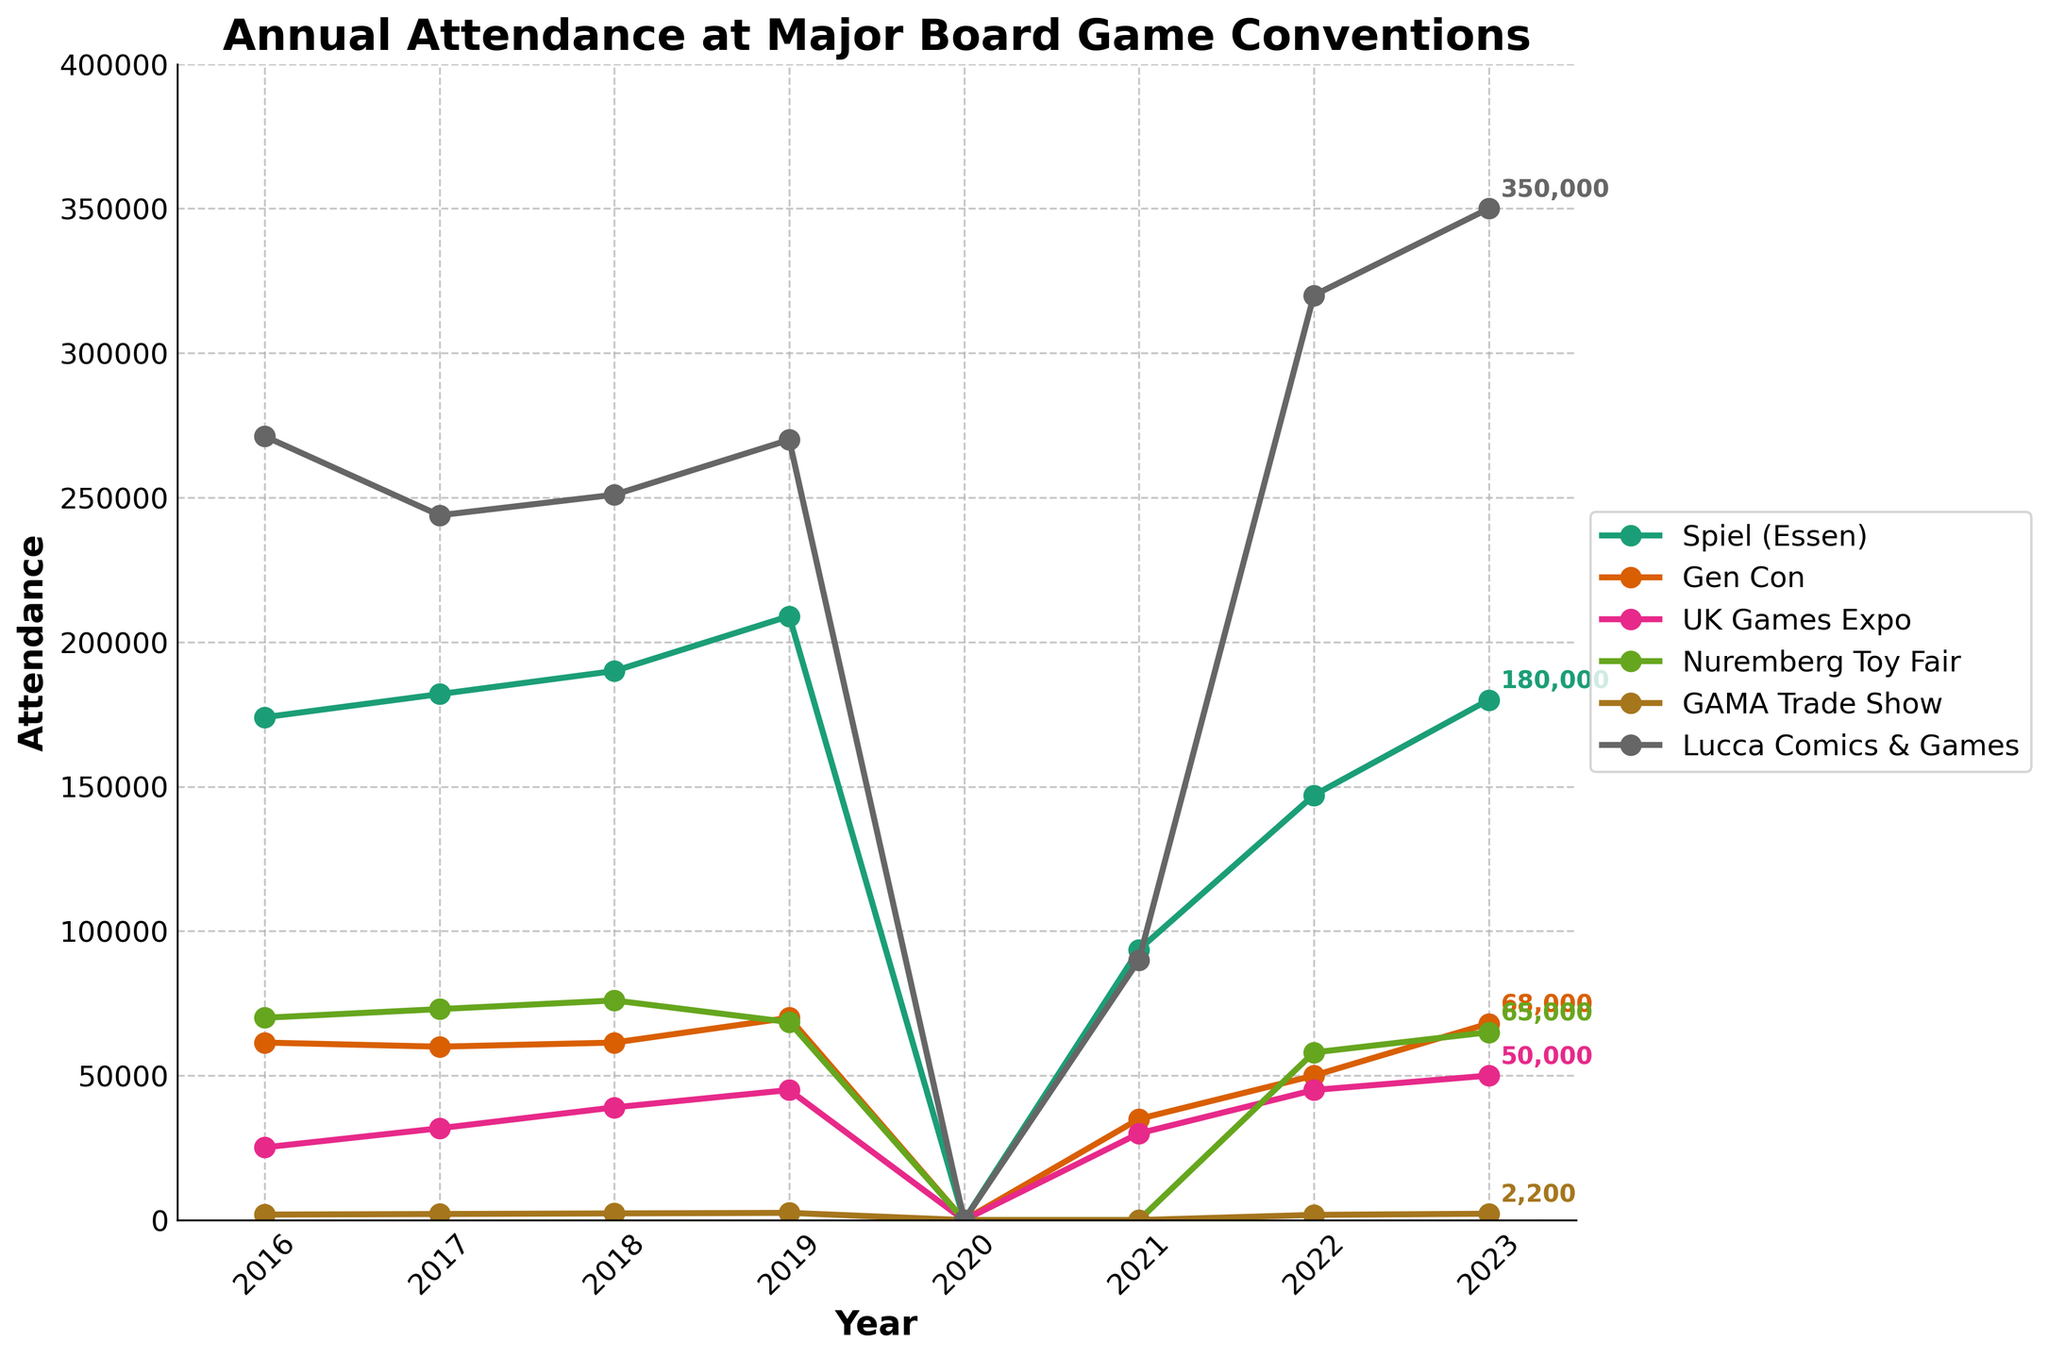What was the attendance at Spiel (Essen) in 2019 compared to Gen Con in the same year? Look at Spiel (Essen) and Gen Con attendance in 2019. Spiel (Essen) had 209,000 attendees and Gen Con had 70,000 attendees.
Answer: Spiel (Essen): 209,000, Gen Con: 70,000 Which convention had the highest attendance in 2023? Check the attendance figures for all conventions in 2023. Lucca Comics & Games had the highest attendance with 350,000 attendees.
Answer: Lucca Comics & Games How did UK Games Expo attendance change from 2016 to 2023? In 2016, UK Games Expo had 25,149 attendees; by 2023, it had 50,000 attendees. The attendance increased by 50,000 - 25,149 = 24,851 attendees.
Answer: Increased by 24,851 Which convention showed the most consistent increase in attendance from 2016 to 2023? Generate a trend analysis by looking at the graph lines. Spiel (Essen) shows a consistent increase in attendance from 2016 to 2023 except for the dip in 2020 due to the pandemic.
Answer: Spiel (Essen) What is the difference in attendance between the highest and lowest attended conventions in 2022? The highest attendance in 2022 was Lucca Comics & Games (320,000) and the lowest was GAMA Trade Show (1,800). The difference is 320,000 - 1,800 = 318,200.
Answer: 318,200 What was the attendance trend for Nuremberg Toy Fair from 2016 to 2023? The Nuremberg Toy Fair had fluctuating attendance with 70,000 in 2016, increasing to 76,000 in 2018, dipping to 68,500 in 2019, zero in 2020, and rising again to 65,000 in 2023.
Answer: Fluctuating Between 2016 and 2019, which convention had the highest cumulative attendance? Sum the attendances from 2016 to 2019 for each convention. Spiel (Essen) has the highest cumulative total: 174,000 + 182,000 + 190,000 + 209,000 = 755,000.
Answer: Spiel (Essen) What was the average attendance at UK Games Expo from 2016 to 2023, excluding years with zero attendance? Sum the annual attendances for UK Games Expo and divide by non-zero years: (25,149 + 31,764 + 39,000 + 45,000 + 30,000 + 45,000 + 50,000) / 7 = 37,702.43.
Answer: 37,702.43 Which year showed a sharp decline in attendance across all conventions, and what was the cause? Observe the figure showing zero attendance for all conventions in 2020. Assume the cause was likely due to the COVID-19 pandemic.
Answer: 2020, COVID-19 pandemic In which year did Lucca Comics & Games see its highest attendance, and what was the figure? Look at Lucca Comics & Games attendance over the years; the highest attendance was in 2023 with 350,000.
Answer: 2023, 350,000 